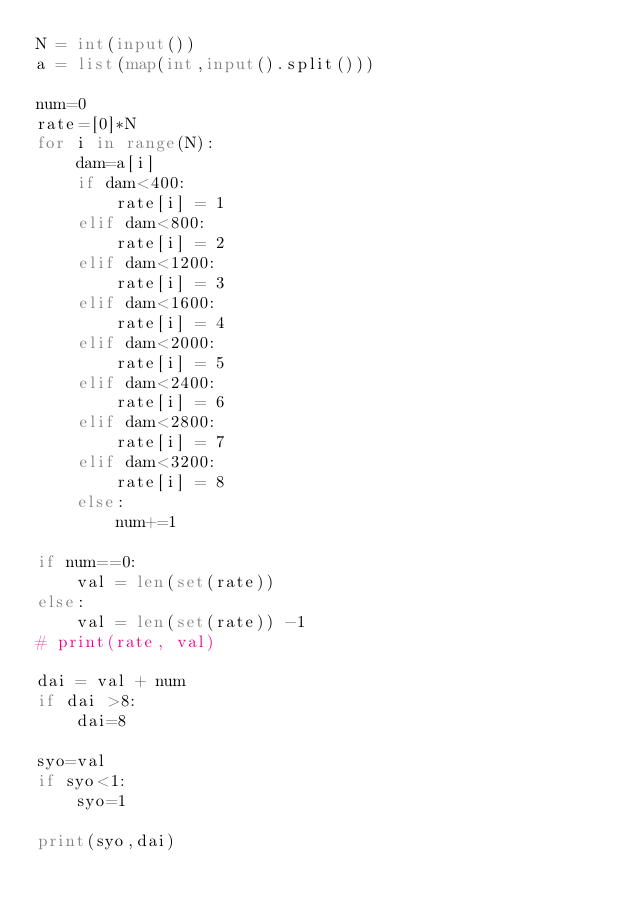Convert code to text. <code><loc_0><loc_0><loc_500><loc_500><_Python_>N = int(input())
a = list(map(int,input().split()))

num=0
rate=[0]*N
for i in range(N):
    dam=a[i]
    if dam<400:
        rate[i] = 1
    elif dam<800:
        rate[i] = 2
    elif dam<1200:
        rate[i] = 3
    elif dam<1600:
        rate[i] = 4
    elif dam<2000:
        rate[i] = 5
    elif dam<2400:
        rate[i] = 6
    elif dam<2800:
        rate[i] = 7
    elif dam<3200:
        rate[i] = 8
    else:
        num+=1

if num==0:
    val = len(set(rate))
else:
    val = len(set(rate)) -1
# print(rate, val)

dai = val + num
if dai >8:
    dai=8

syo=val
if syo<1:
    syo=1

print(syo,dai)</code> 